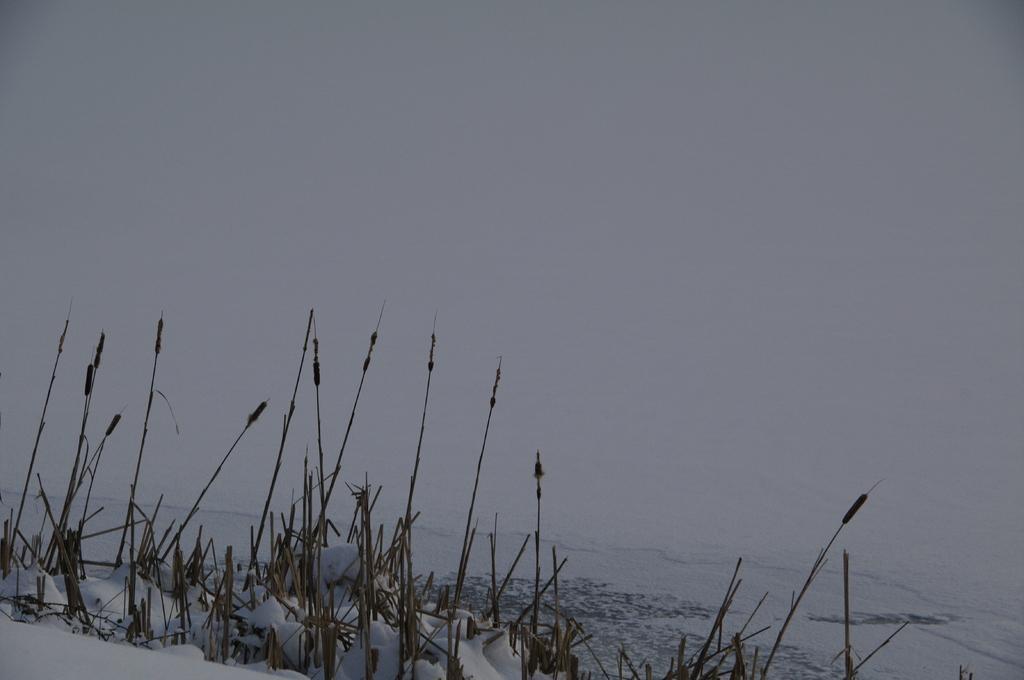Could you give a brief overview of what you see in this image? In this image at the bottom there is snow and some plants, and there is a white background. 